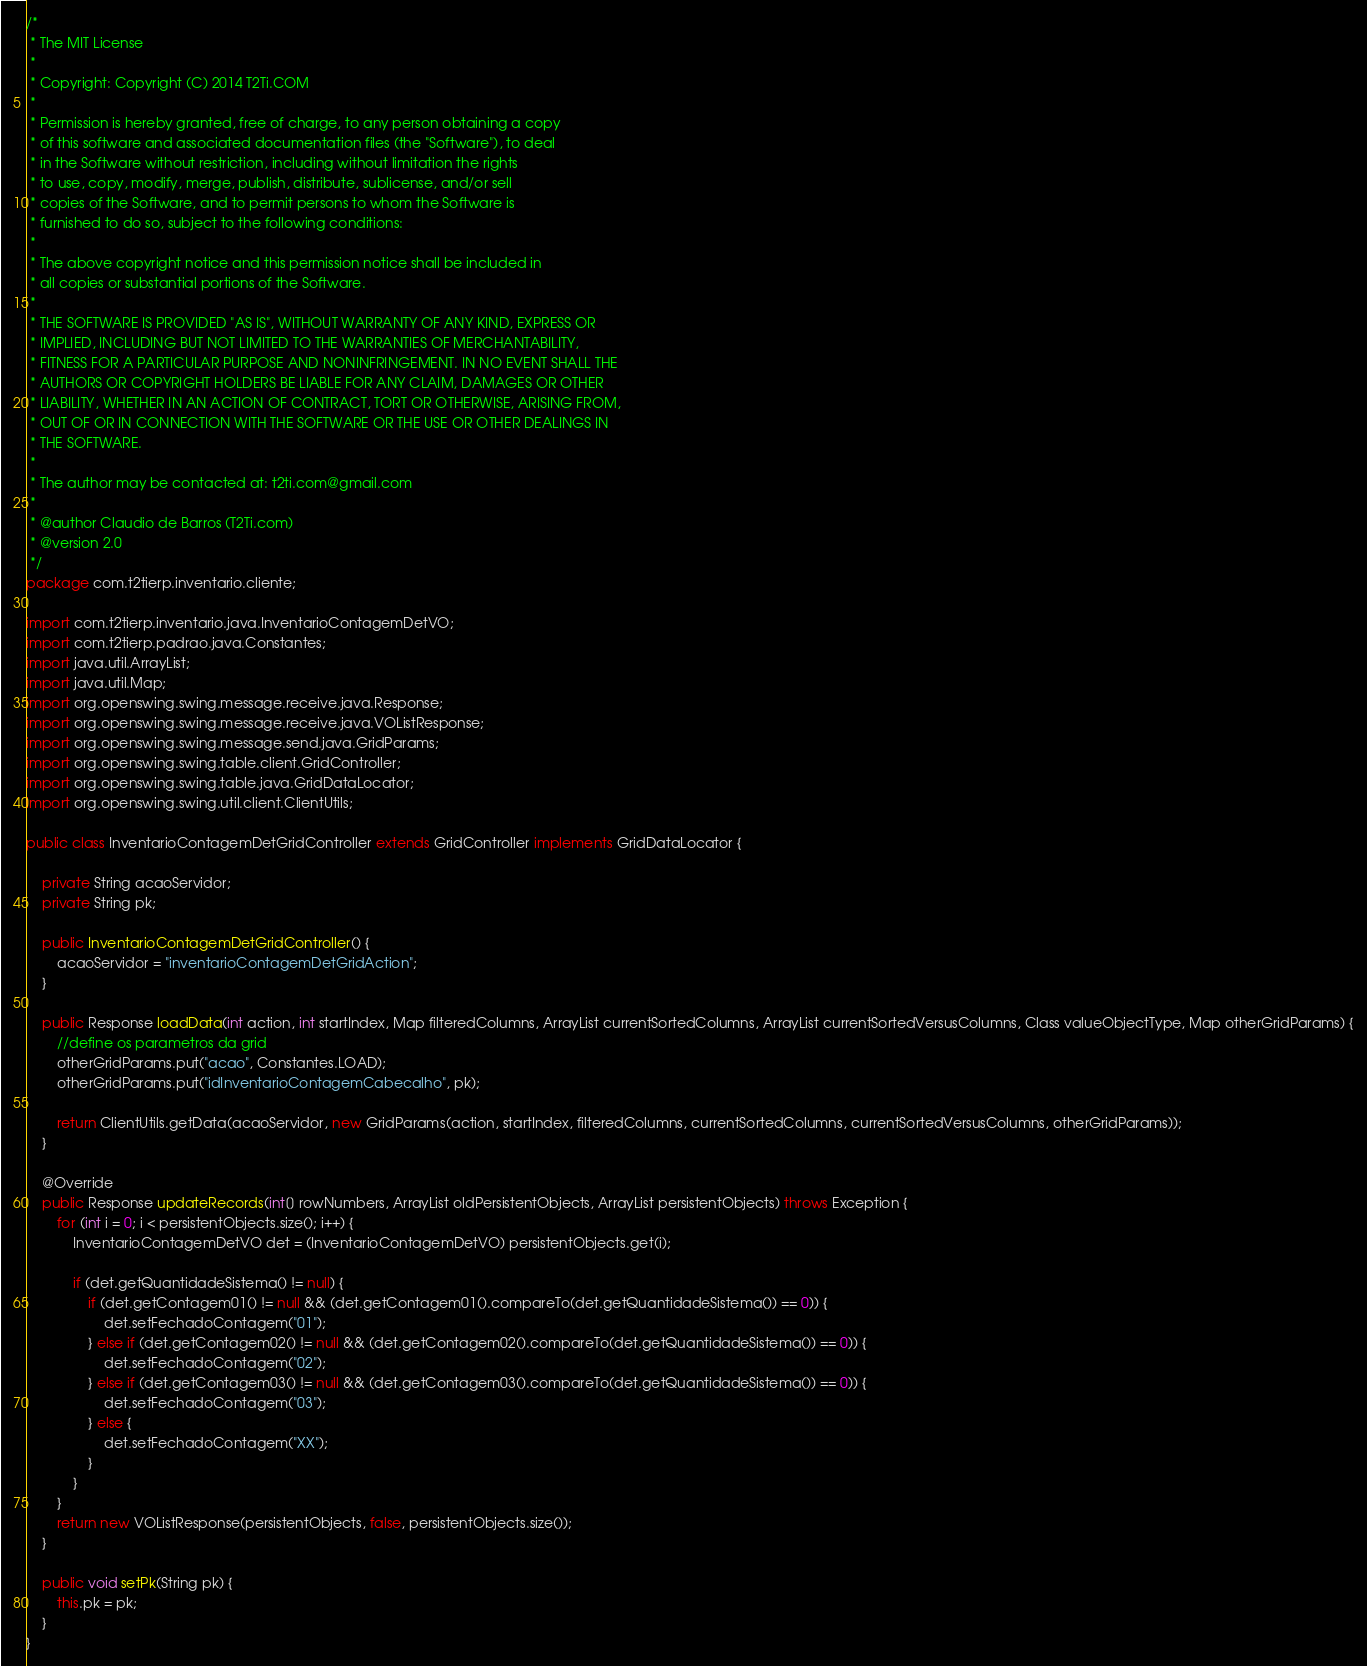<code> <loc_0><loc_0><loc_500><loc_500><_Java_>/*
 * The MIT License
 * 
 * Copyright: Copyright (C) 2014 T2Ti.COM
 * 
 * Permission is hereby granted, free of charge, to any person obtaining a copy
 * of this software and associated documentation files (the "Software"), to deal
 * in the Software without restriction, including without limitation the rights
 * to use, copy, modify, merge, publish, distribute, sublicense, and/or sell
 * copies of the Software, and to permit persons to whom the Software is
 * furnished to do so, subject to the following conditions:
 * 
 * The above copyright notice and this permission notice shall be included in
 * all copies or substantial portions of the Software.
 * 
 * THE SOFTWARE IS PROVIDED "AS IS", WITHOUT WARRANTY OF ANY KIND, EXPRESS OR
 * IMPLIED, INCLUDING BUT NOT LIMITED TO THE WARRANTIES OF MERCHANTABILITY,
 * FITNESS FOR A PARTICULAR PURPOSE AND NONINFRINGEMENT. IN NO EVENT SHALL THE
 * AUTHORS OR COPYRIGHT HOLDERS BE LIABLE FOR ANY CLAIM, DAMAGES OR OTHER
 * LIABILITY, WHETHER IN AN ACTION OF CONTRACT, TORT OR OTHERWISE, ARISING FROM,
 * OUT OF OR IN CONNECTION WITH THE SOFTWARE OR THE USE OR OTHER DEALINGS IN
 * THE SOFTWARE.
 * 
 * The author may be contacted at: t2ti.com@gmail.com
 *
 * @author Claudio de Barros (T2Ti.com)
 * @version 2.0
 */
package com.t2tierp.inventario.cliente;

import com.t2tierp.inventario.java.InventarioContagemDetVO;
import com.t2tierp.padrao.java.Constantes;
import java.util.ArrayList;
import java.util.Map;
import org.openswing.swing.message.receive.java.Response;
import org.openswing.swing.message.receive.java.VOListResponse;
import org.openswing.swing.message.send.java.GridParams;
import org.openswing.swing.table.client.GridController;
import org.openswing.swing.table.java.GridDataLocator;
import org.openswing.swing.util.client.ClientUtils;

public class InventarioContagemDetGridController extends GridController implements GridDataLocator {

    private String acaoServidor;
    private String pk;

    public InventarioContagemDetGridController() {
        acaoServidor = "inventarioContagemDetGridAction";
    }

    public Response loadData(int action, int startIndex, Map filteredColumns, ArrayList currentSortedColumns, ArrayList currentSortedVersusColumns, Class valueObjectType, Map otherGridParams) {
        //define os parametros da grid
        otherGridParams.put("acao", Constantes.LOAD);
        otherGridParams.put("idInventarioContagemCabecalho", pk);

        return ClientUtils.getData(acaoServidor, new GridParams(action, startIndex, filteredColumns, currentSortedColumns, currentSortedVersusColumns, otherGridParams));
    }

    @Override
    public Response updateRecords(int[] rowNumbers, ArrayList oldPersistentObjects, ArrayList persistentObjects) throws Exception {
        for (int i = 0; i < persistentObjects.size(); i++) {
            InventarioContagemDetVO det = (InventarioContagemDetVO) persistentObjects.get(i);

            if (det.getQuantidadeSistema() != null) {
                if (det.getContagem01() != null && (det.getContagem01().compareTo(det.getQuantidadeSistema()) == 0)) {
                    det.setFechadoContagem("01");
                } else if (det.getContagem02() != null && (det.getContagem02().compareTo(det.getQuantidadeSistema()) == 0)) {
                    det.setFechadoContagem("02");
                } else if (det.getContagem03() != null && (det.getContagem03().compareTo(det.getQuantidadeSistema()) == 0)) {
                    det.setFechadoContagem("03");
                } else {
                    det.setFechadoContagem("XX");
                }
            }
        }
        return new VOListResponse(persistentObjects, false, persistentObjects.size());
    }

    public void setPk(String pk) {
        this.pk = pk;
    }
}
</code> 